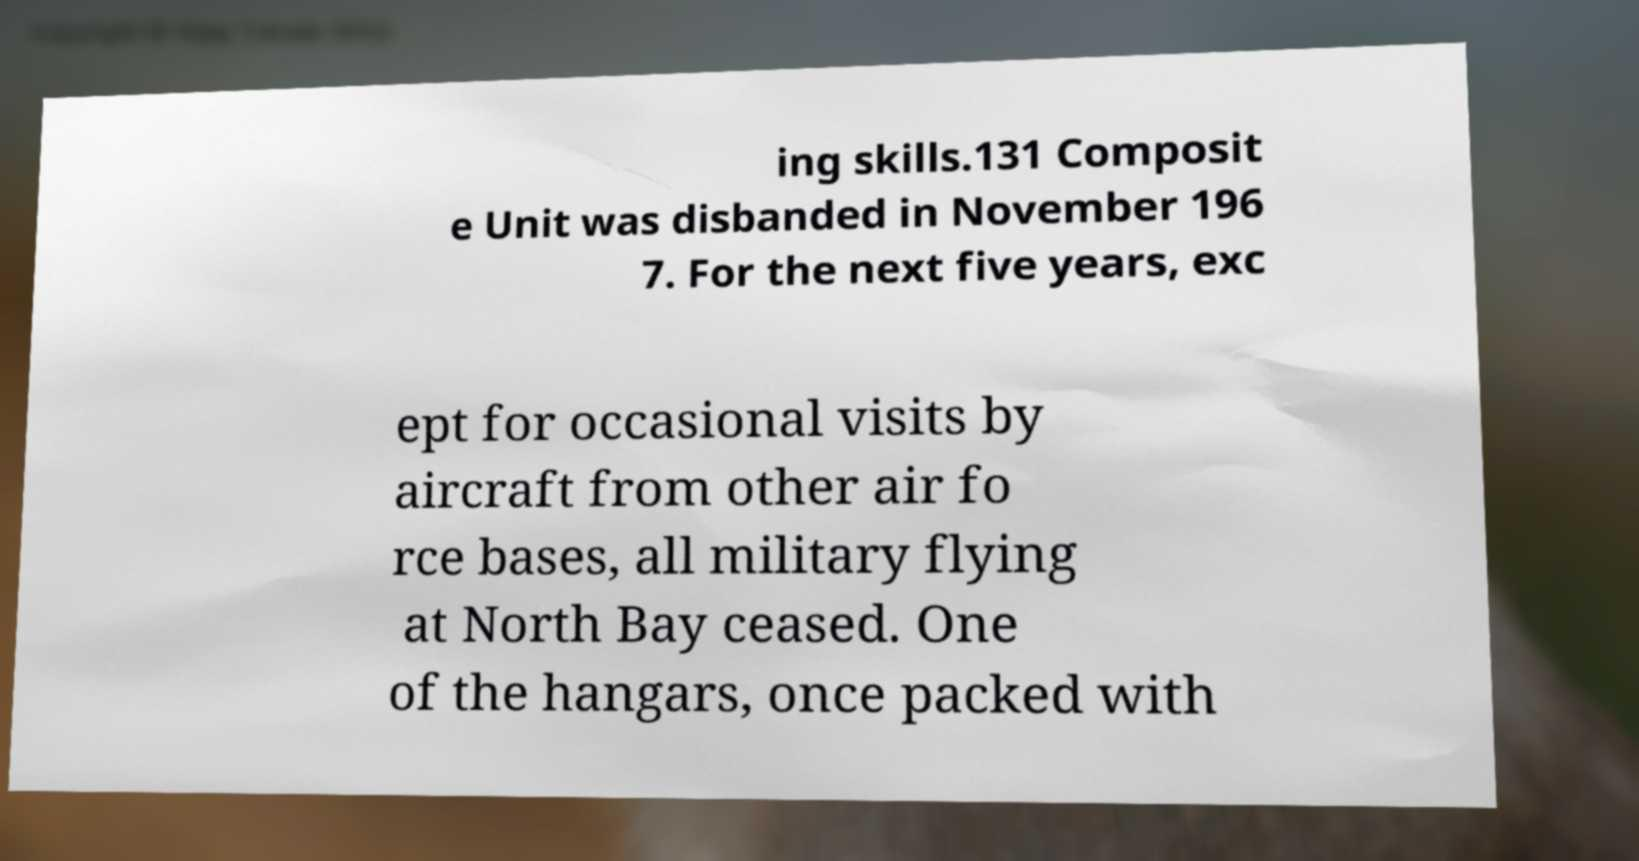Can you read and provide the text displayed in the image?This photo seems to have some interesting text. Can you extract and type it out for me? ing skills.131 Composit e Unit was disbanded in November 196 7. For the next five years, exc ept for occasional visits by aircraft from other air fo rce bases, all military flying at North Bay ceased. One of the hangars, once packed with 